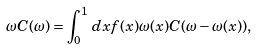<formula> <loc_0><loc_0><loc_500><loc_500>\omega C ( \omega ) = \int _ { 0 } ^ { 1 } \, d x f ( x ) \omega ( x ) C ( \omega - \omega ( x ) ) ,</formula> 